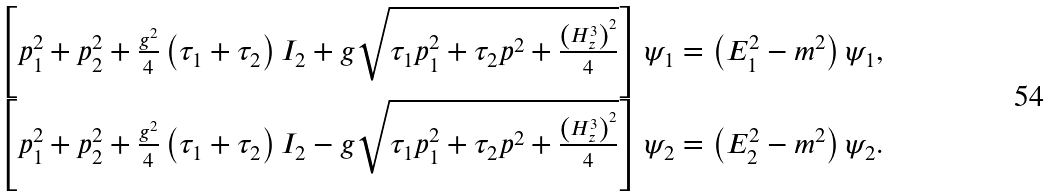Convert formula to latex. <formula><loc_0><loc_0><loc_500><loc_500>\begin{array} { c } \left [ p _ { 1 } ^ { 2 } + p _ { 2 } ^ { 2 } + \frac { g ^ { 2 } } 4 \left ( \tau _ { 1 } + \tau _ { 2 } \right ) I _ { 2 } + g \sqrt { \tau _ { 1 } p _ { 1 } ^ { 2 } + \tau _ { 2 } p ^ { 2 } + \frac { \left ( H _ { z } ^ { 3 } \right ) ^ { 2 } } 4 } \right ] \psi _ { 1 } = \left ( E _ { 1 } ^ { 2 } - m ^ { 2 } \right ) \psi _ { 1 } , \\ \left [ p _ { 1 } ^ { 2 } + p _ { 2 } ^ { 2 } + \frac { g ^ { 2 } } 4 \left ( \tau _ { 1 } + \tau _ { 2 } \right ) I _ { 2 } - g \sqrt { \tau _ { 1 } p _ { 1 } ^ { 2 } + \tau _ { 2 } p ^ { 2 } + \frac { \left ( H _ { z } ^ { 3 } \right ) ^ { 2 } } 4 } \right ] \psi _ { 2 } = \left ( E _ { 2 } ^ { 2 } - m ^ { 2 } \right ) \psi _ { 2 } . \end{array}</formula> 